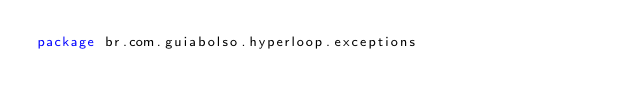<code> <loc_0><loc_0><loc_500><loc_500><_Kotlin_>package br.com.guiabolso.hyperloop.exceptions
</code> 